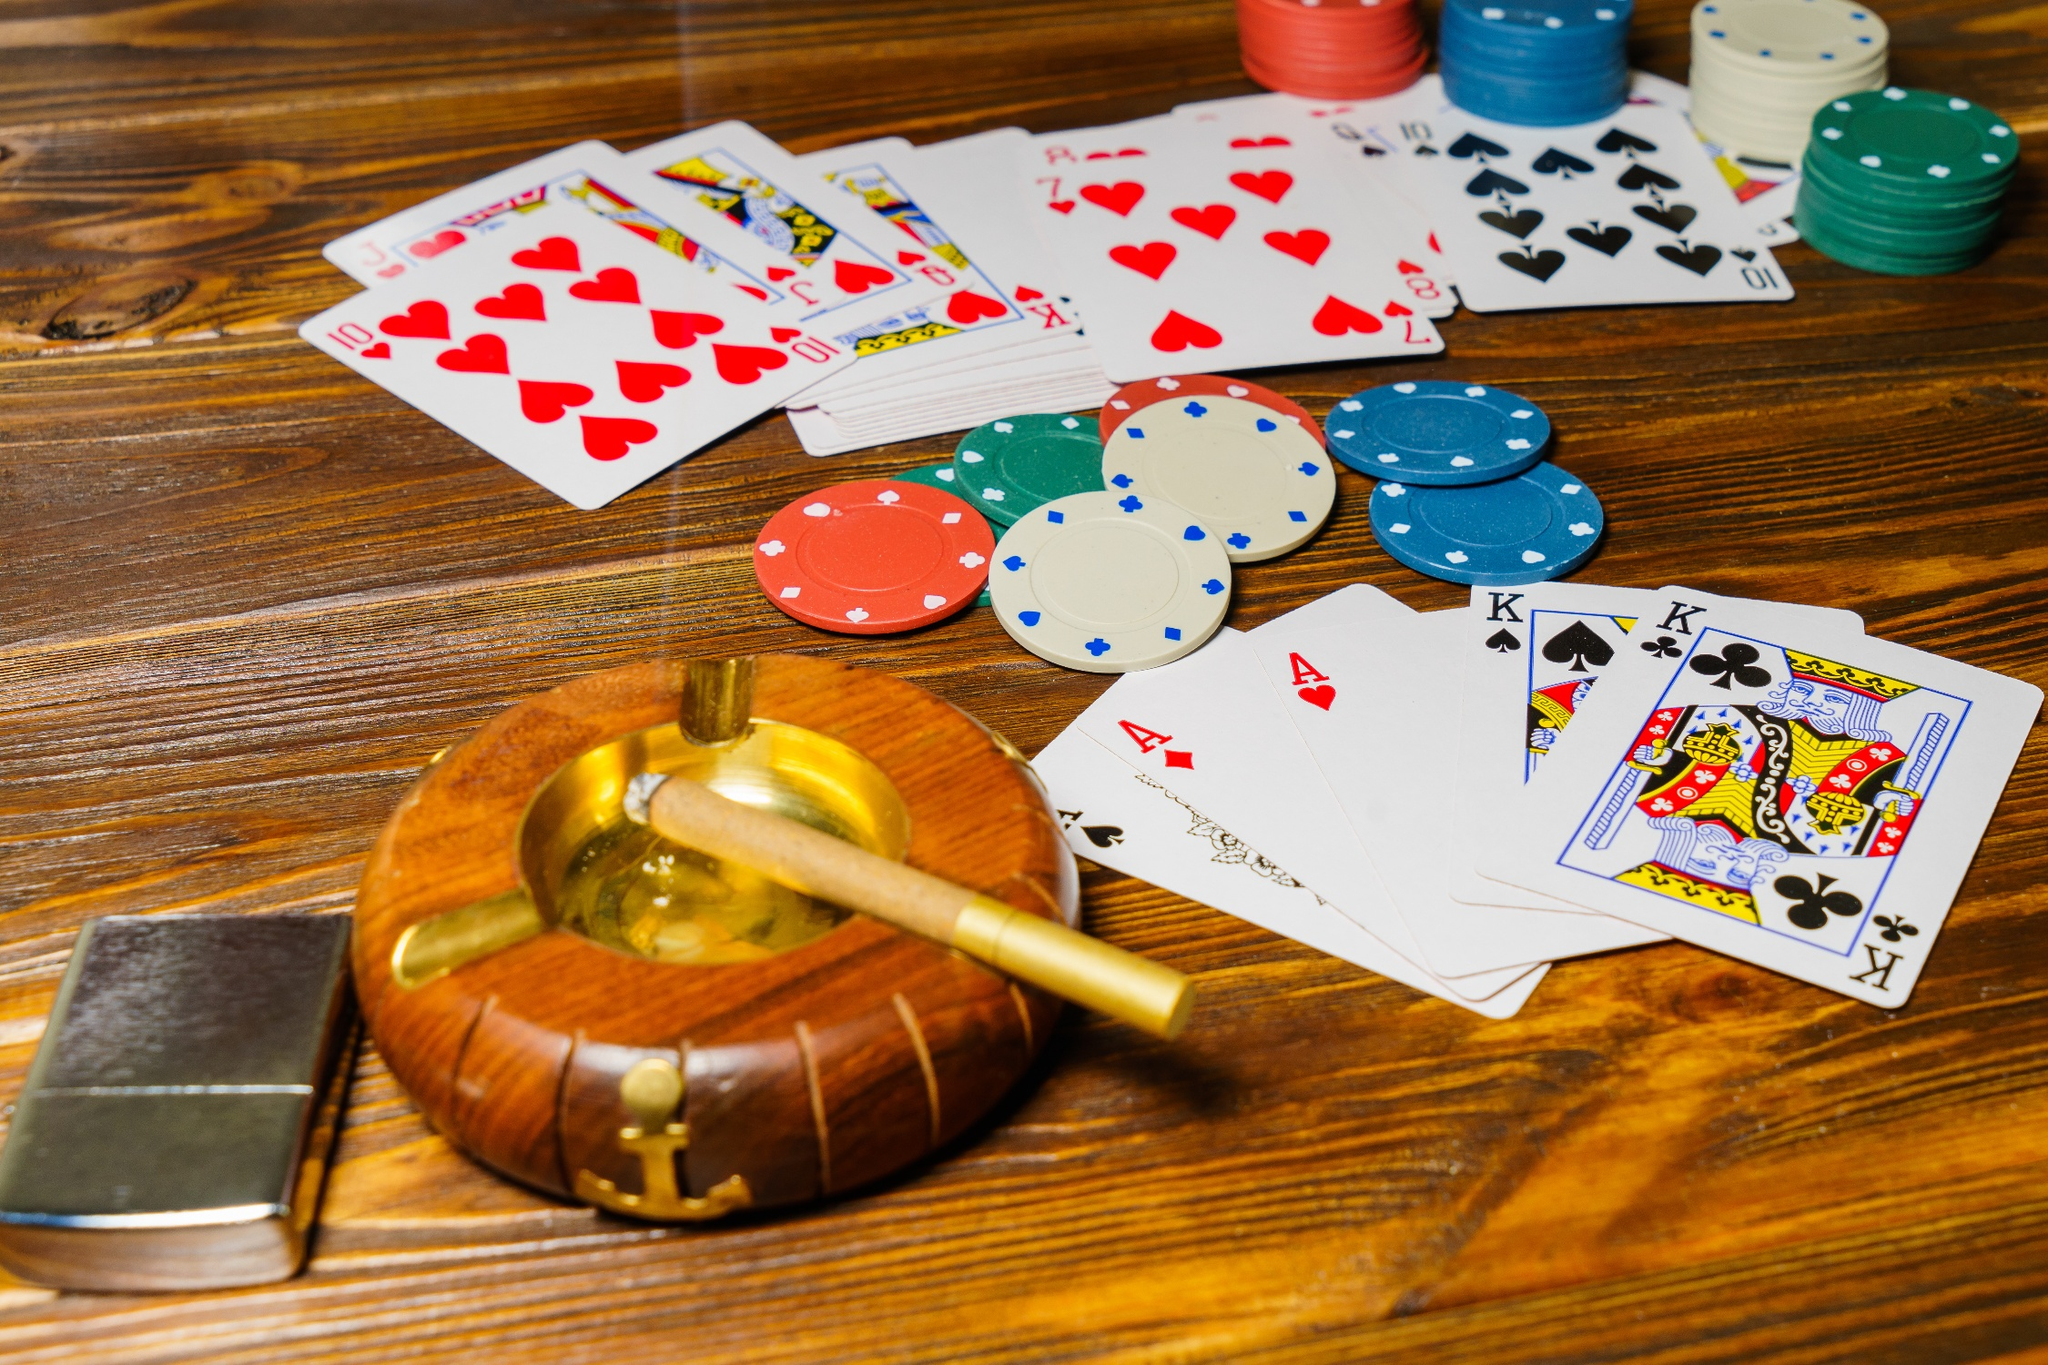What is this photo about'? The image vividly depicts a scene from an ongoing poker game. The high-angle view provides a thorough look at a wooden table covered with a colorful assortment of poker chips in blue, green, red, and yellow. The chips are thoughtfully arranged in neat stacks, showcasing the ongoing bets of the game. Scattered playing cards, showing a range of suits and numbers, add to the strategic complexity depicted. In the foreground lies a wooden ashtray with a smoldering cigar, infusing the scene with an aura of sophistication and intensity. The warm brown hues of the table and ashtray are punctuated beautifully by the vibrant colors of the chips and the cool-colored playing cards, capturing the thrill and anticipation inherent in a poker game. The image encapsulates the spirit of competition and the refined atmosphere of a casino night. 